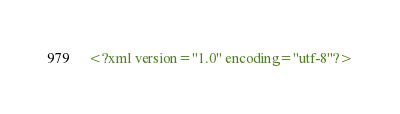<code> <loc_0><loc_0><loc_500><loc_500><_XML_><?xml version="1.0" encoding="utf-8"?></code> 